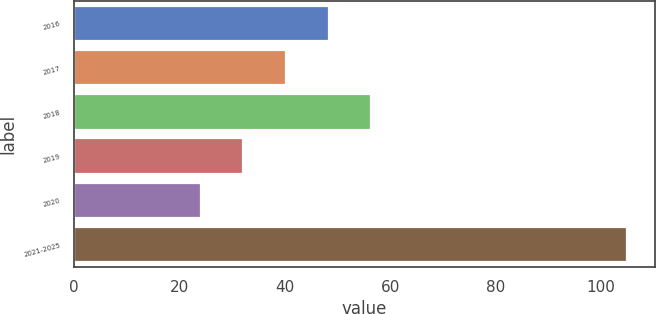<chart> <loc_0><loc_0><loc_500><loc_500><bar_chart><fcel>2016<fcel>2017<fcel>2018<fcel>2019<fcel>2020<fcel>2021-2025<nl><fcel>48.3<fcel>40.2<fcel>56.4<fcel>32.1<fcel>24<fcel>105<nl></chart> 